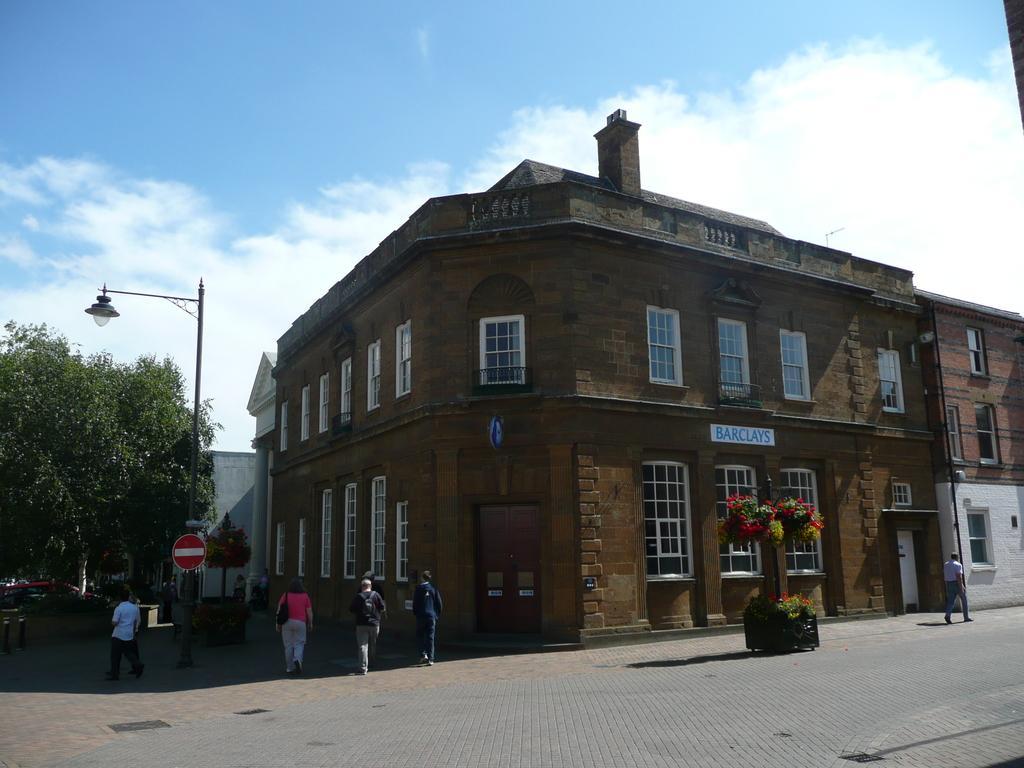Could you give a brief overview of what you see in this image? In this image there is a surface at bottom of this image. there is one plant at right side of this image and there is one person standing at right side to this plant and there is a building in the background. There is a tree at left side of this image and there are some persons standing at bottom left side of this image. there is a pole at left side of this image and there is a cloudy sky at top of this image. 